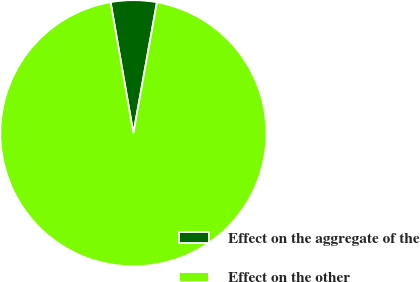Convert chart to OTSL. <chart><loc_0><loc_0><loc_500><loc_500><pie_chart><fcel>Effect on the aggregate of the<fcel>Effect on the other<nl><fcel>5.57%<fcel>94.43%<nl></chart> 